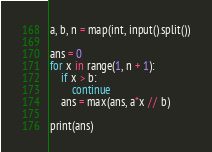Convert code to text. <code><loc_0><loc_0><loc_500><loc_500><_Python_>a, b, n = map(int, input().split())

ans = 0
for x in range(1, n + 1):
    if x > b:
        continue
    ans = max(ans, a*x // b)

print(ans)</code> 